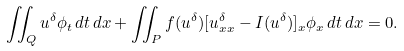<formula> <loc_0><loc_0><loc_500><loc_500>\iint _ { Q } u ^ { \delta } \phi _ { t } \, d t \, d x + \iint _ { P } f ( u ^ { \delta } ) [ u ^ { \delta } _ { x x } - I ( u ^ { \delta } ) ] _ { x } \phi _ { x } \, d t \, d x = 0 .</formula> 